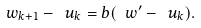<formula> <loc_0><loc_0><loc_500><loc_500>\ w _ { k + 1 } - \ u _ { k } = b ( \ w ^ { \prime } - \ u _ { k } ) .</formula> 